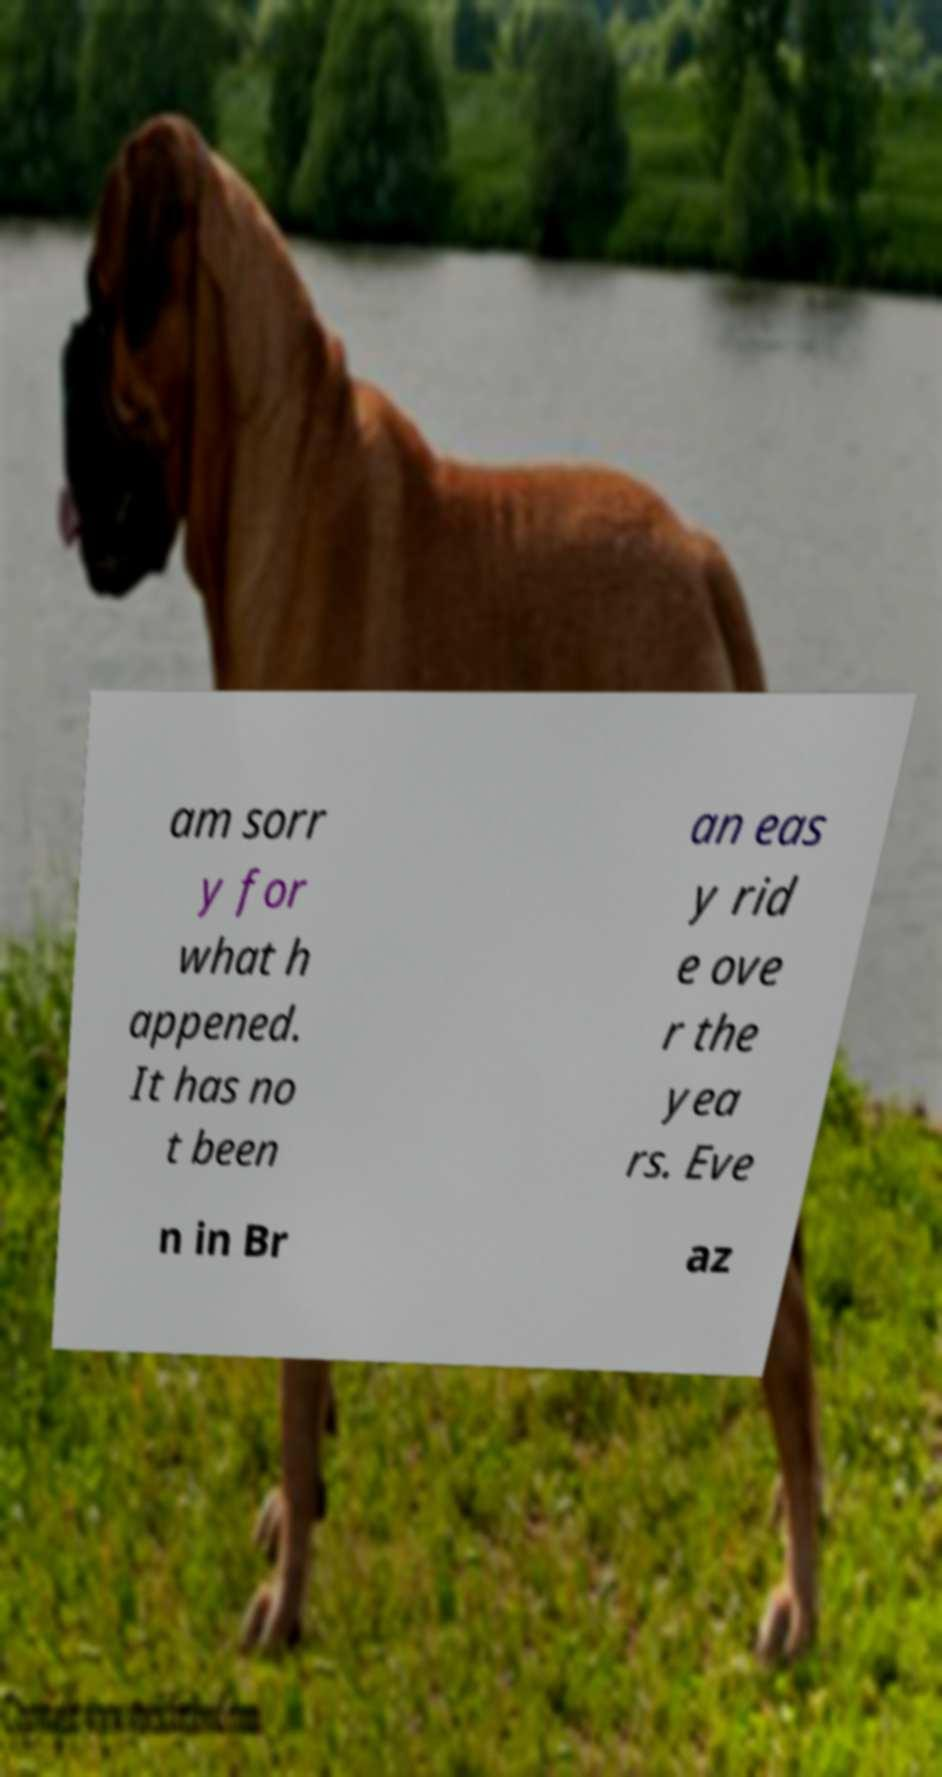For documentation purposes, I need the text within this image transcribed. Could you provide that? am sorr y for what h appened. It has no t been an eas y rid e ove r the yea rs. Eve n in Br az 